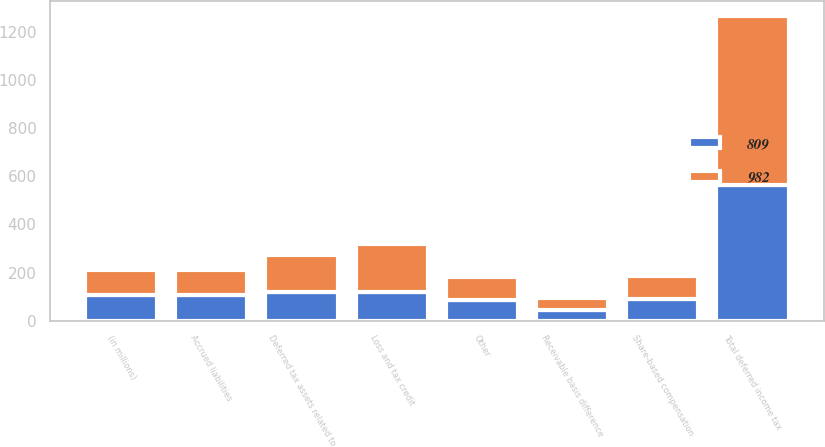<chart> <loc_0><loc_0><loc_500><loc_500><stacked_bar_chart><ecel><fcel>(in millions)<fcel>Receivable basis difference<fcel>Accrued liabilities<fcel>Share-based compensation<fcel>Loss and tax credit<fcel>Deferred tax assets related to<fcel>Other<fcel>Total deferred income tax<nl><fcel>809<fcel>106<fcel>46<fcel>107<fcel>90<fcel>120<fcel>118<fcel>85<fcel>566<nl><fcel>982<fcel>106<fcel>46<fcel>105<fcel>97<fcel>199<fcel>157<fcel>97<fcel>701<nl></chart> 